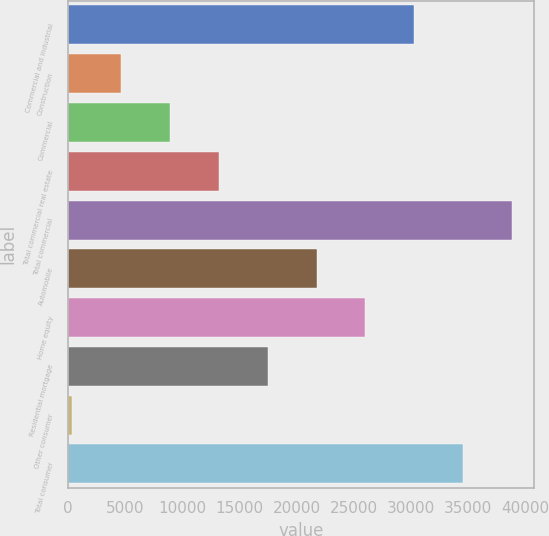Convert chart. <chart><loc_0><loc_0><loc_500><loc_500><bar_chart><fcel>Commercial and industrial<fcel>Construction<fcel>Commercial<fcel>Total commercial real estate<fcel>Total commercial<fcel>Automobile<fcel>Home equity<fcel>Residential mortgage<fcel>Other consumer<fcel>Total consumer<nl><fcel>30298<fcel>4654<fcel>8928<fcel>13202<fcel>38846<fcel>21750<fcel>26024<fcel>17476<fcel>380<fcel>34572<nl></chart> 